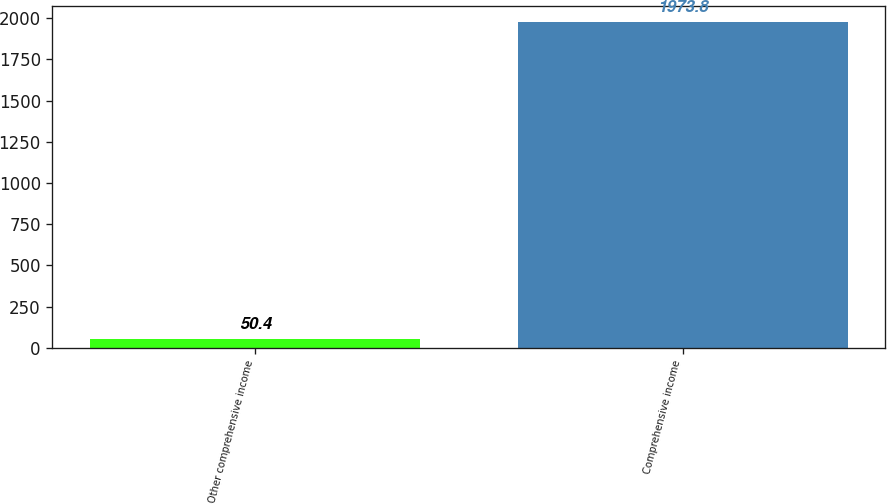<chart> <loc_0><loc_0><loc_500><loc_500><bar_chart><fcel>Other comprehensive income<fcel>Comprehensive income<nl><fcel>50.4<fcel>1973.8<nl></chart> 